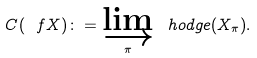<formula> <loc_0><loc_0><loc_500><loc_500>C ( \ f X ) \colon = \varinjlim _ { \pi } \ h o d g e ( X _ { \pi } ) .</formula> 